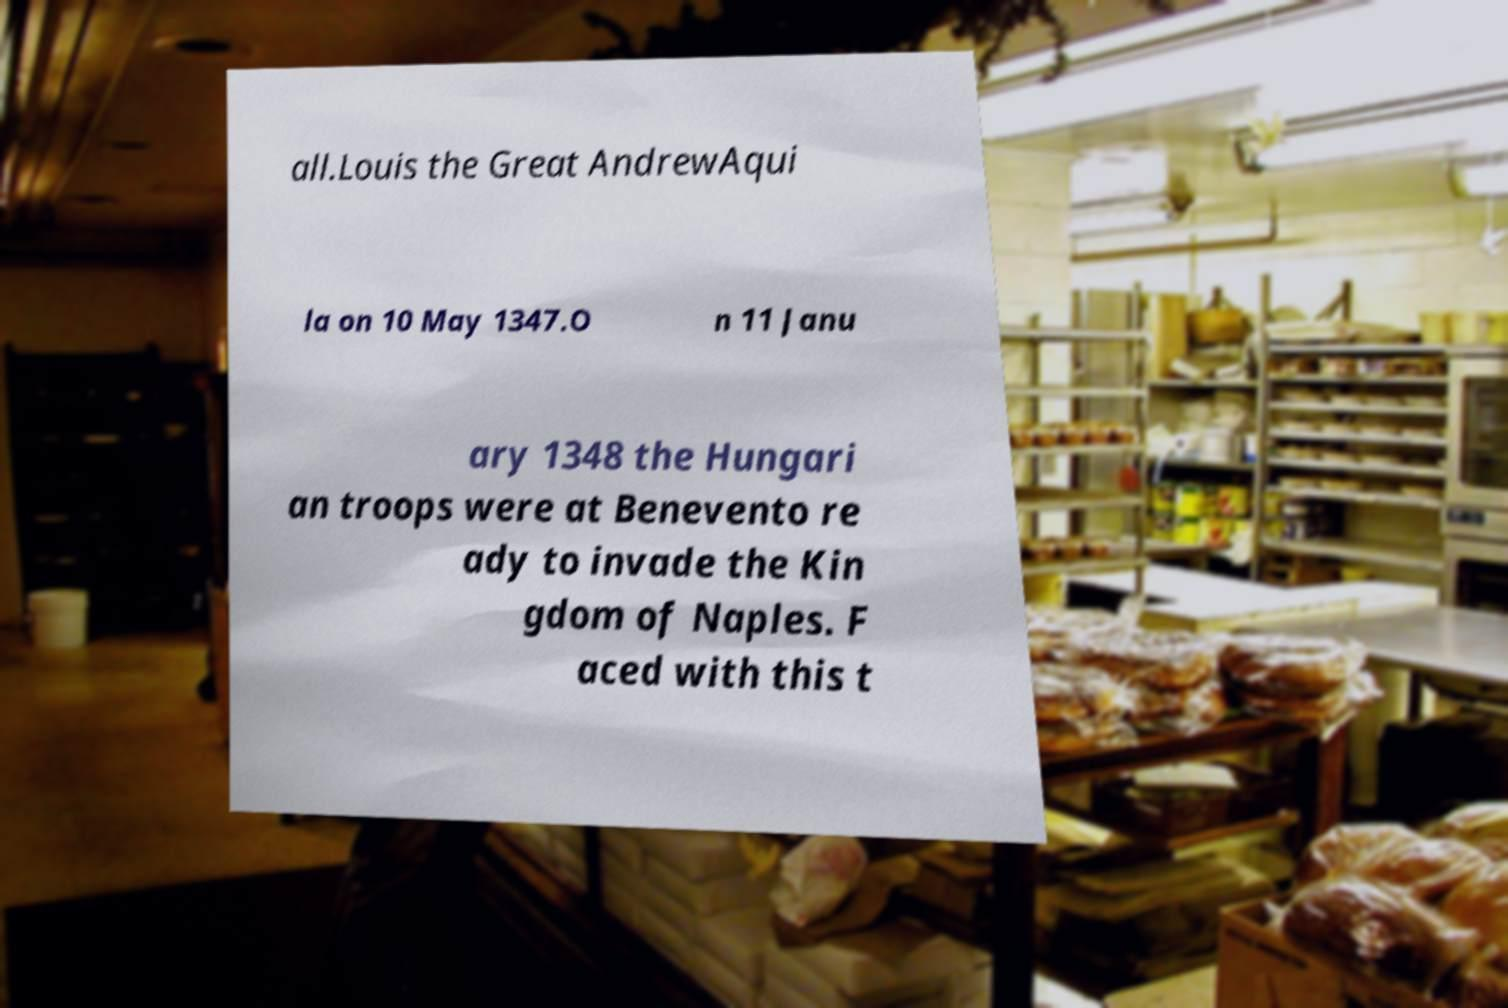Could you extract and type out the text from this image? all.Louis the Great AndrewAqui la on 10 May 1347.O n 11 Janu ary 1348 the Hungari an troops were at Benevento re ady to invade the Kin gdom of Naples. F aced with this t 